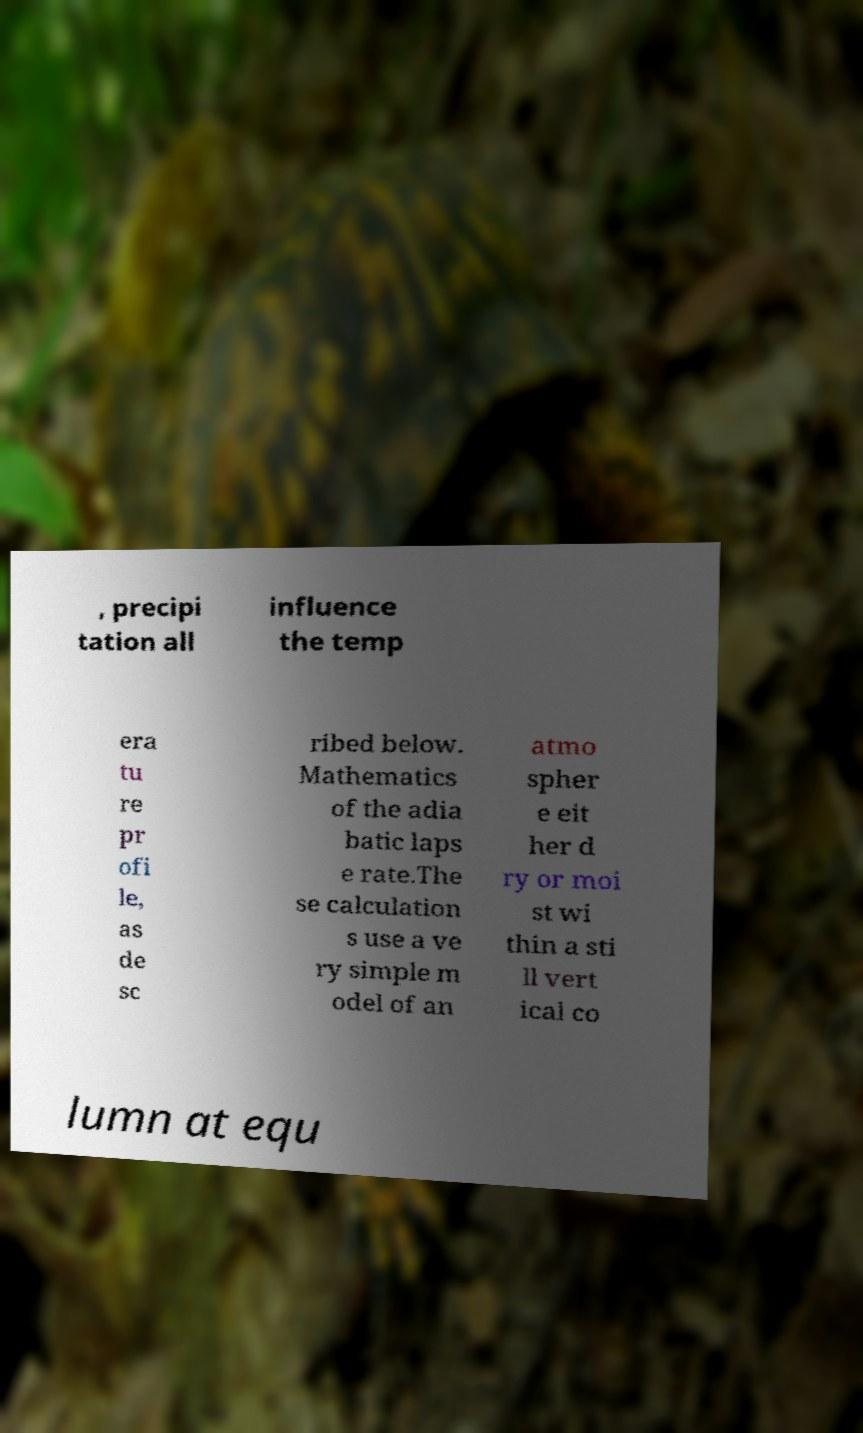Can you accurately transcribe the text from the provided image for me? , precipi tation all influence the temp era tu re pr ofi le, as de sc ribed below. Mathematics of the adia batic laps e rate.The se calculation s use a ve ry simple m odel of an atmo spher e eit her d ry or moi st wi thin a sti ll vert ical co lumn at equ 